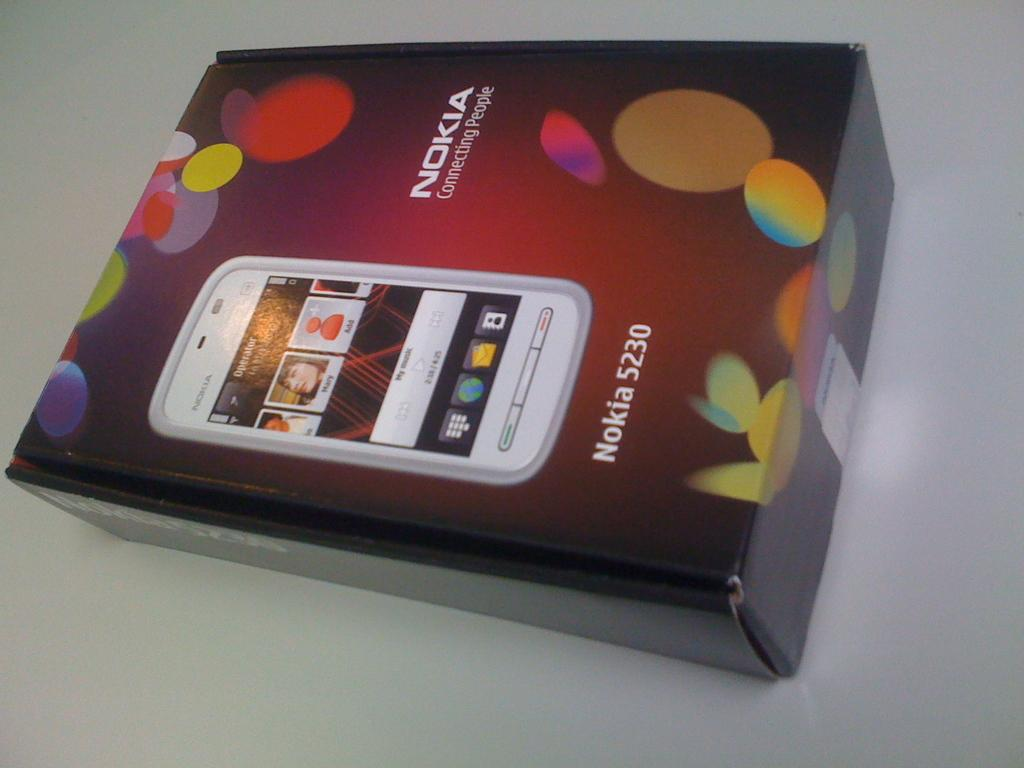<image>
Describe the image concisely. a box that has Nokia written on the front of it 